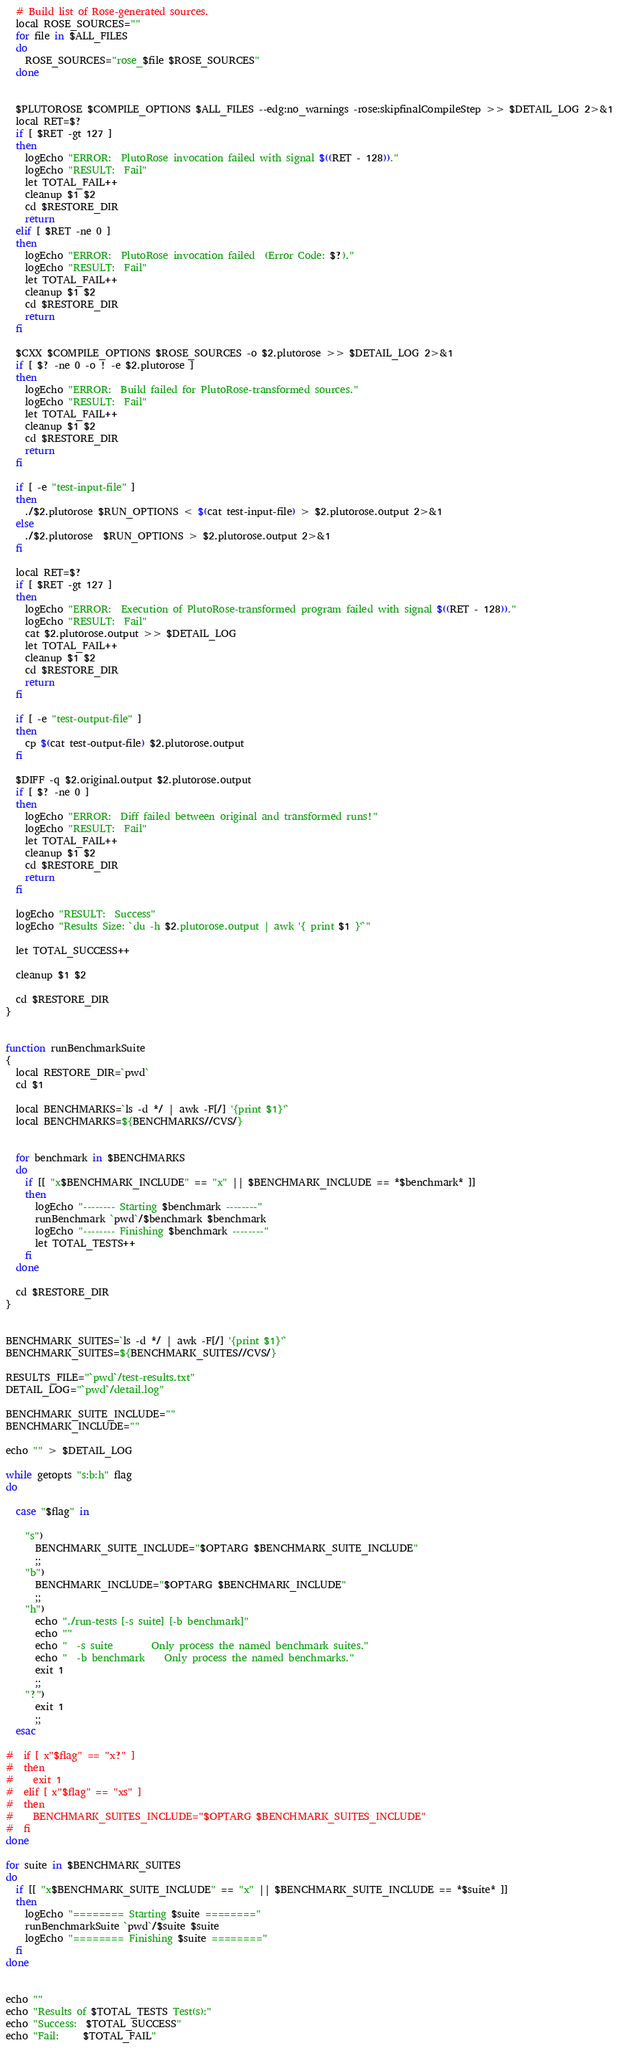<code> <loc_0><loc_0><loc_500><loc_500><_Bash_>
  # Build list of Rose-generated sources.
  local ROSE_SOURCES=""
  for file in $ALL_FILES
  do
    ROSE_SOURCES="rose_$file $ROSE_SOURCES"
  done
  

  $PLUTOROSE $COMPILE_OPTIONS $ALL_FILES --edg:no_warnings -rose:skipfinalCompileStep >> $DETAIL_LOG 2>&1
  local RET=$?
  if [ $RET -gt 127 ]
  then
    logEcho "ERROR:  PlutoRose invocation failed with signal $((RET - 128))."
    logEcho "RESULT:  Fail"
    let TOTAL_FAIL++
    cleanup $1 $2
    cd $RESTORE_DIR
    return
  elif [ $RET -ne 0 ]
  then
    logEcho "ERROR:  PlutoRose invocation failed  (Error Code: $?)."
    logEcho "RESULT:  Fail"
    let TOTAL_FAIL++
    cleanup $1 $2
    cd $RESTORE_DIR
    return
  fi

  $CXX $COMPILE_OPTIONS $ROSE_SOURCES -o $2.plutorose >> $DETAIL_LOG 2>&1
  if [ $? -ne 0 -o ! -e $2.plutorose ]
  then
    logEcho "ERROR:  Build failed for PlutoRose-transformed sources."
    logEcho "RESULT:  Fail"
    let TOTAL_FAIL++
    cleanup $1 $2
    cd $RESTORE_DIR
    return
  fi

  if [ -e "test-input-file" ]
  then
    ./$2.plutorose $RUN_OPTIONS < $(cat test-input-file) > $2.plutorose.output 2>&1
  else
    ./$2.plutorose  $RUN_OPTIONS > $2.plutorose.output 2>&1
  fi

  local RET=$?
  if [ $RET -gt 127 ]
  then
    logEcho "ERROR:  Execution of PlutoRose-transformed program failed with signal $((RET - 128))."
    logEcho "RESULT:  Fail"
    cat $2.plutorose.output >> $DETAIL_LOG
    let TOTAL_FAIL++
    cleanup $1 $2
    cd $RESTORE_DIR
    return
  fi

  if [ -e "test-output-file" ]
  then
    cp $(cat test-output-file) $2.plutorose.output
  fi
  
  $DIFF -q $2.original.output $2.plutorose.output
  if [ $? -ne 0 ]
  then
    logEcho "ERROR:  Diff failed between original and transformed runs!"
    logEcho "RESULT:  Fail"
    let TOTAL_FAIL++
    cleanup $1 $2
    cd $RESTORE_DIR
    return
  fi

  logEcho "RESULT:  Success"
  logEcho "Results Size: `du -h $2.plutorose.output | awk '{ print $1 }'`"

  let TOTAL_SUCCESS++

  cleanup $1 $2

  cd $RESTORE_DIR
}


function runBenchmarkSuite
{
  local RESTORE_DIR=`pwd`
  cd $1

  local BENCHMARKS=`ls -d */ | awk -F[/] '{print $1}'`
  local BENCHMARKS=${BENCHMARKS//CVS/}

  
  for benchmark in $BENCHMARKS
  do
    if [[ "x$BENCHMARK_INCLUDE" == "x" || $BENCHMARK_INCLUDE == *$benchmark* ]]
    then
      logEcho "-------- Starting $benchmark --------"
      runBenchmark `pwd`/$benchmark $benchmark
      logEcho "-------- Finishing $benchmark --------"
      let TOTAL_TESTS++
    fi
  done

  cd $RESTORE_DIR
}


BENCHMARK_SUITES=`ls -d */ | awk -F[/] '{print $1}'`
BENCHMARK_SUITES=${BENCHMARK_SUITES//CVS/}

RESULTS_FILE="`pwd`/test-results.txt"
DETAIL_LOG="`pwd`/detail.log"

BENCHMARK_SUITE_INCLUDE=""
BENCHMARK_INCLUDE=""

echo "" > $DETAIL_LOG

while getopts "s:b:h" flag
do

  case "$flag" in

    "s")
      BENCHMARK_SUITE_INCLUDE="$OPTARG $BENCHMARK_SUITE_INCLUDE"
      ;;
    "b")
      BENCHMARK_INCLUDE="$OPTARG $BENCHMARK_INCLUDE"
      ;;
    "h")
      echo "./run-tests [-s suite] [-b benchmark]"
      echo ""
      echo "  -s suite        Only process the named benchmark suites."
      echo "  -b benchmark    Only process the named benchmarks."
      exit 1
      ;;
    "?")
      exit 1
      ;;
  esac

#  if [ x"$flag" == "x?" ]
#  then
#    exit 1
#  elif [ x"$flag" == "xs" ]
#  then
#    BENCHMARK_SUITES_INCLUDE="$OPTARG $BENCHMARK_SUITES_INCLUDE"
#  fi
done

for suite in $BENCHMARK_SUITES
do
  if [[ "x$BENCHMARK_SUITE_INCLUDE" == "x" || $BENCHMARK_SUITE_INCLUDE == *$suite* ]]
  then
    logEcho "======== Starting $suite ========"
    runBenchmarkSuite `pwd`/$suite $suite
    logEcho "======== Finishing $suite ========"
  fi
done


echo ""
echo "Results of $TOTAL_TESTS Test(s):"
echo "Success:  $TOTAL_SUCCESS"
echo "Fail:     $TOTAL_FAIL"

</code> 